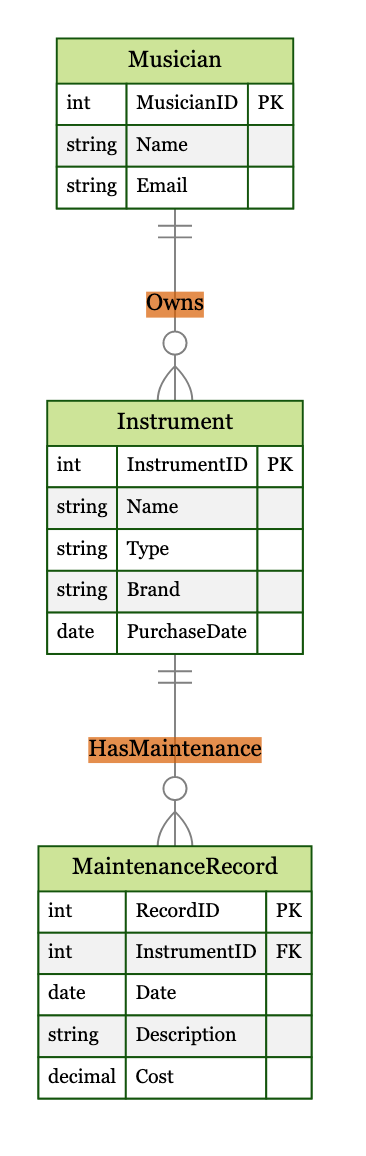What are the attributes of the Musician entity? The Musician entity has three attributes: MusicianID, Name, and Email. Each attribute is listed under the Musician entity in the diagram.
Answer: MusicianID, Name, Email How many attributes does the Instrument entity have? The Instrument entity includes five attributes: InstrumentID, Name, Type, Brand, and PurchaseDate. Counting these gives a total of five attributes.
Answer: 5 What relationship exists between Musician and Instrument? The relationship between Musician and Instrument is labeled as "Owns," indicating that a Musician can own multiple Instruments. This relationship is shown with a 1 to many notation from Musician to Instrument.
Answer: Owns What relationship exists between Instrument and MaintenanceRecord? The relationship is labeled as "HasMaintenance," indicating that each Instrument can have multiple MaintenanceRecords. This is shown with a 1 to many notation from Instrument to MaintenanceRecord.
Answer: HasMaintenance What is the primary key of the MaintenanceRecord entity? The primary key for the MaintenanceRecord entity is RecordID, which uniquely identifies each maintenance record. This is specified in the attributes section of the MaintenanceRecord entity.
Answer: RecordID How many foreign keys are present in the MaintenanceRecord entity? The MaintenanceRecord entity has one foreign key: InstrumentID, which references the Instrument entity to link maintenance records to a specific instrument.
Answer: 1 What type of relationship is depicted between Instrument and MaintenanceRecord? The diagram shows a 1 to many relationship between Instrument and MaintenanceRecord, indicating that one instrument can have multiple maintenance records associated with it.
Answer: 1 to many What is the PurchaseDate attribute of the Instrument entity? The PurchaseDate attribute represents the date when the instrument was purchased and is defined in the attributes of the Instrument entity in the diagram.
Answer: PurchaseDate How many entities are depicted in the diagram? The diagram depicts three entities: Musician, Instrument, and MaintenanceRecord. Counting these gives a total of three entities in the diagram.
Answer: 3 